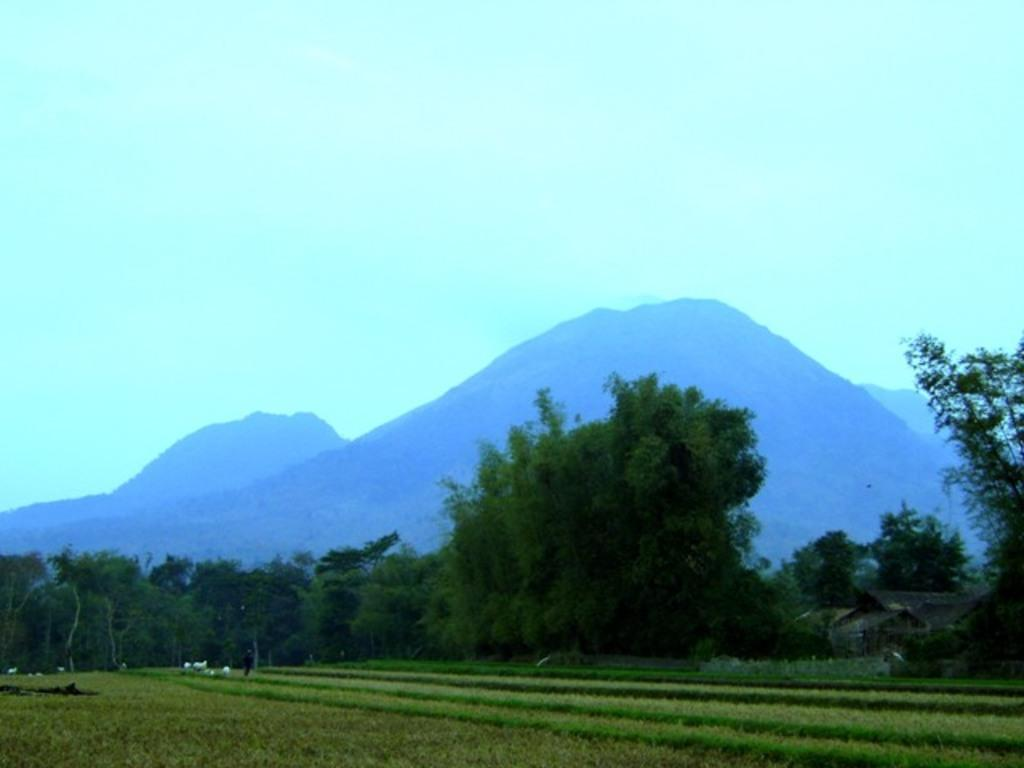What type of vegetation can be seen in the foreground of the image? There are crops in the foreground of the image. What other natural elements are present in the image? There are trees in the middle of the image and hills in the background of the image. What is visible at the top of the image? The sky is visible at the top of the image. What color is the crayon used to draw the hills in the image? There is no crayon present in the image; it is a photograph of real hills. How does the sea affect the crops in the foreground of the image? There is no sea present in the image; it features crops, trees, hills, and the sky. 